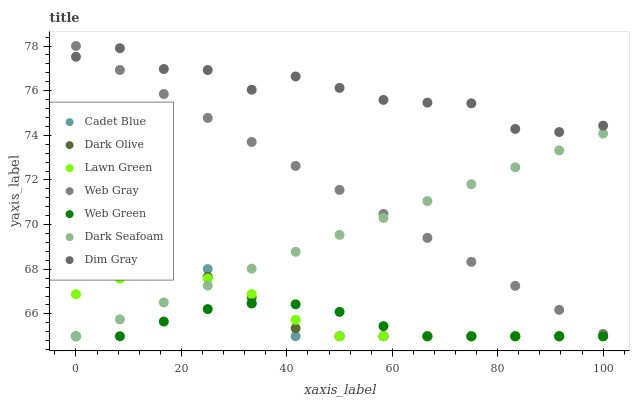Does Web Green have the minimum area under the curve?
Answer yes or no. Yes. Does Dim Gray have the maximum area under the curve?
Answer yes or no. Yes. Does Cadet Blue have the minimum area under the curve?
Answer yes or no. No. Does Cadet Blue have the maximum area under the curve?
Answer yes or no. No. Is Web Gray the smoothest?
Answer yes or no. Yes. Is Dim Gray the roughest?
Answer yes or no. Yes. Is Cadet Blue the smoothest?
Answer yes or no. No. Is Cadet Blue the roughest?
Answer yes or no. No. Does Lawn Green have the lowest value?
Answer yes or no. Yes. Does Dim Gray have the lowest value?
Answer yes or no. No. Does Web Gray have the highest value?
Answer yes or no. Yes. Does Cadet Blue have the highest value?
Answer yes or no. No. Is Lawn Green less than Web Gray?
Answer yes or no. Yes. Is Dim Gray greater than Dark Olive?
Answer yes or no. Yes. Does Dark Seafoam intersect Cadet Blue?
Answer yes or no. Yes. Is Dark Seafoam less than Cadet Blue?
Answer yes or no. No. Is Dark Seafoam greater than Cadet Blue?
Answer yes or no. No. Does Lawn Green intersect Web Gray?
Answer yes or no. No. 